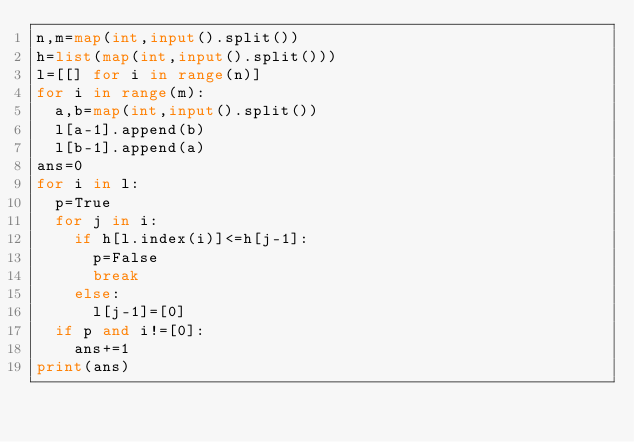<code> <loc_0><loc_0><loc_500><loc_500><_Python_>n,m=map(int,input().split())
h=list(map(int,input().split()))
l=[[] for i in range(n)]
for i in range(m):
  a,b=map(int,input().split())
  l[a-1].append(b)
  l[b-1].append(a)
ans=0
for i in l:
  p=True
  for j in i:
    if h[l.index(i)]<=h[j-1]:
      p=False
      break
    else:
      l[j-1]=[0]
  if p and i!=[0]:
    ans+=1
print(ans)</code> 